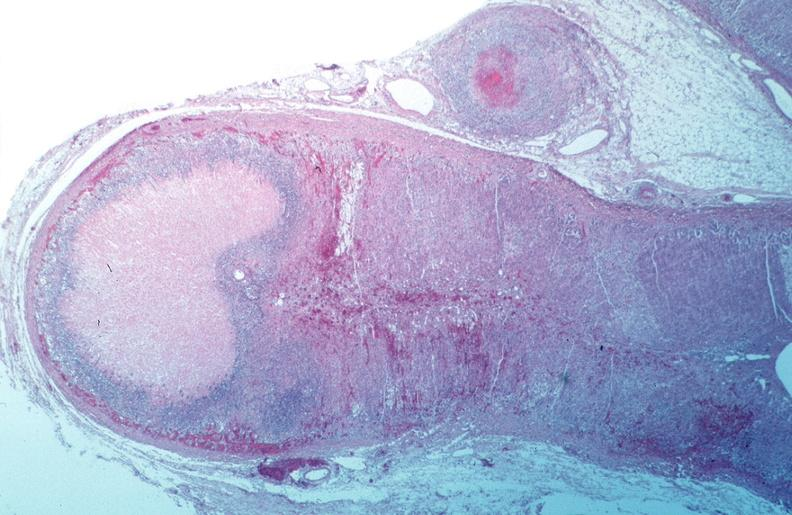s cardiovascular present?
Answer the question using a single word or phrase. No 